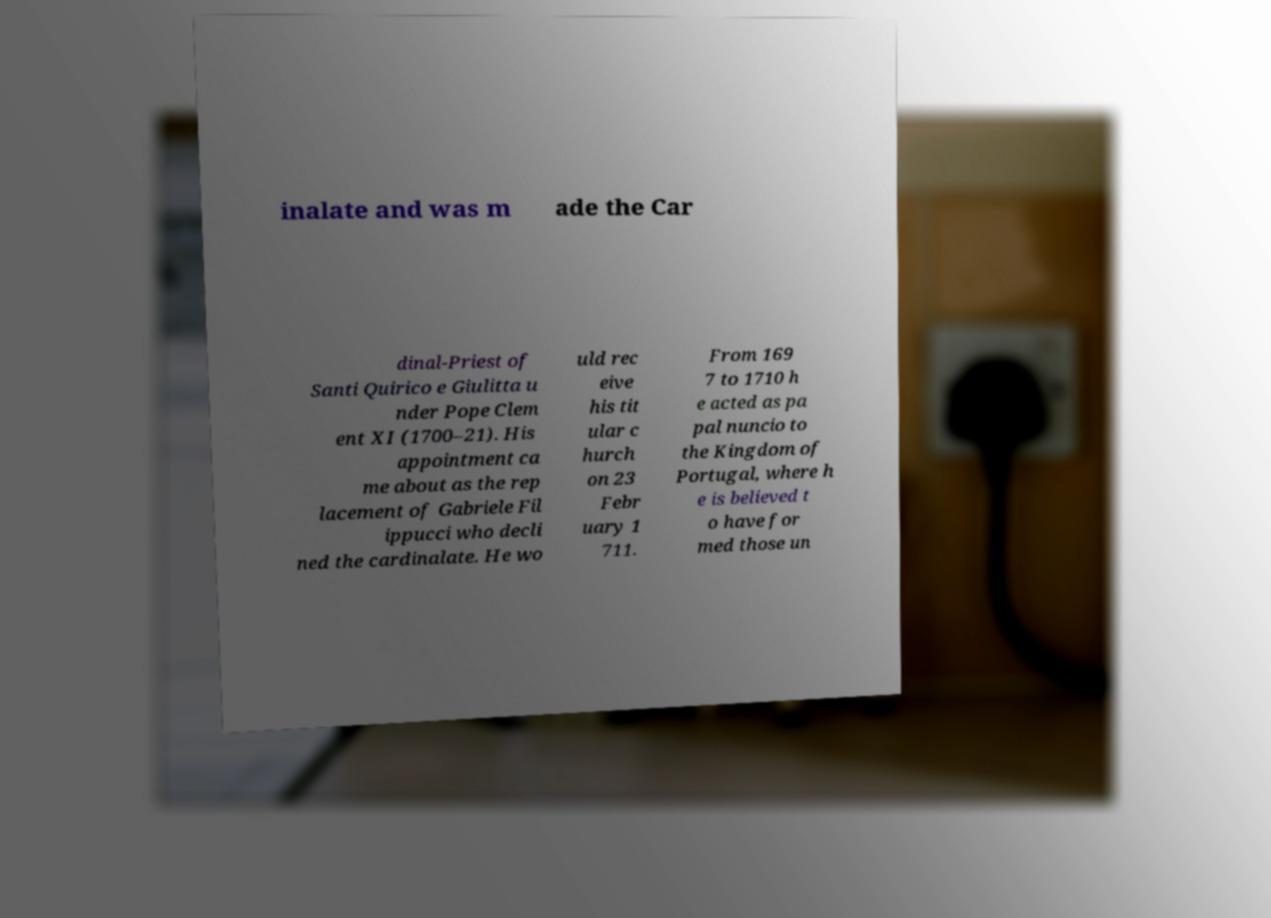There's text embedded in this image that I need extracted. Can you transcribe it verbatim? inalate and was m ade the Car dinal-Priest of Santi Quirico e Giulitta u nder Pope Clem ent XI (1700–21). His appointment ca me about as the rep lacement of Gabriele Fil ippucci who decli ned the cardinalate. He wo uld rec eive his tit ular c hurch on 23 Febr uary 1 711. From 169 7 to 1710 h e acted as pa pal nuncio to the Kingdom of Portugal, where h e is believed t o have for med those un 